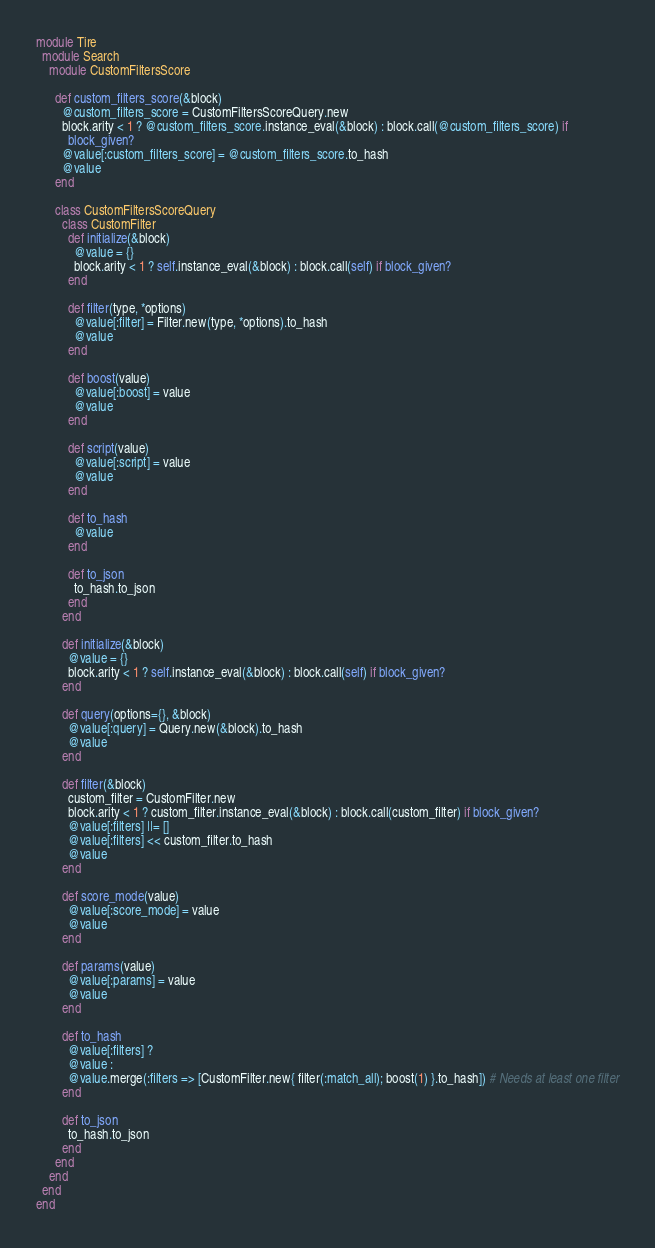Convert code to text. <code><loc_0><loc_0><loc_500><loc_500><_Ruby_>module Tire
  module Search
    module CustomFiltersScore
      
      def custom_filters_score(&block)
        @custom_filters_score = CustomFiltersScoreQuery.new
        block.arity < 1 ? @custom_filters_score.instance_eval(&block) : block.call(@custom_filters_score) if
          block_given?
        @value[:custom_filters_score] = @custom_filters_score.to_hash
        @value
      end
      
      class CustomFiltersScoreQuery
        class CustomFilter
          def initialize(&block)
            @value = {}
            block.arity < 1 ? self.instance_eval(&block) : block.call(self) if block_given?
          end

          def filter(type, *options)
            @value[:filter] = Filter.new(type, *options).to_hash
            @value
          end

          def boost(value)
            @value[:boost] = value
            @value
          end

          def script(value)
            @value[:script] = value
            @value
          end

          def to_hash
            @value
          end

          def to_json
            to_hash.to_json
          end
        end

        def initialize(&block)
          @value = {}
          block.arity < 1 ? self.instance_eval(&block) : block.call(self) if block_given?
        end

        def query(options={}, &block)
          @value[:query] = Query.new(&block).to_hash
          @value
        end

        def filter(&block)
          custom_filter = CustomFilter.new
          block.arity < 1 ? custom_filter.instance_eval(&block) : block.call(custom_filter) if block_given?
          @value[:filters] ||= []
          @value[:filters] << custom_filter.to_hash
          @value
        end

        def score_mode(value)
          @value[:score_mode] = value
          @value
        end

        def params(value)
          @value[:params] = value
          @value
        end

        def to_hash
          @value[:filters] ? 
          @value : 
          @value.merge(:filters => [CustomFilter.new{ filter(:match_all); boost(1) }.to_hash]) # Needs at least one filter
        end

        def to_json
          to_hash.to_json
        end
      end
    end
  end
end</code> 